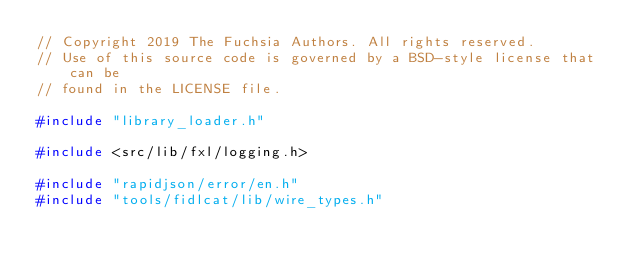<code> <loc_0><loc_0><loc_500><loc_500><_C++_>// Copyright 2019 The Fuchsia Authors. All rights reserved.
// Use of this source code is governed by a BSD-style license that can be
// found in the LICENSE file.

#include "library_loader.h"

#include <src/lib/fxl/logging.h>

#include "rapidjson/error/en.h"
#include "tools/fidlcat/lib/wire_types.h"
</code> 